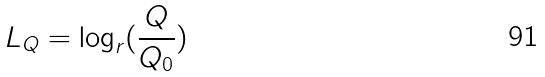Convert formula to latex. <formula><loc_0><loc_0><loc_500><loc_500>L _ { Q } = \log _ { r } ( \frac { Q } { Q _ { 0 } } )</formula> 